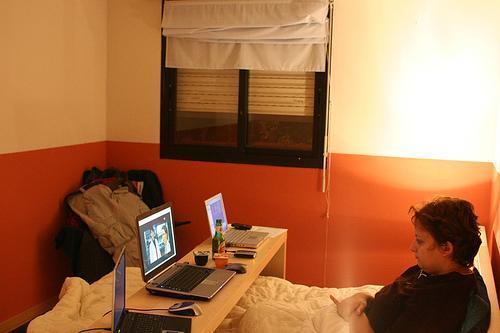How many laptops are there?
Give a very brief answer. 3. How many people are there?
Give a very brief answer. 1. 